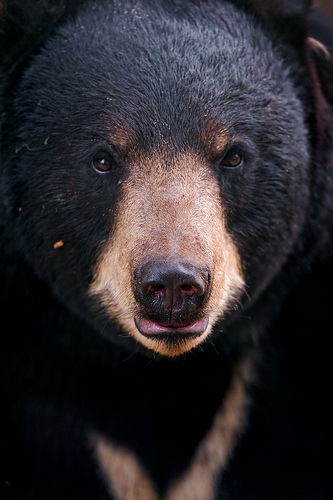Please provide a short description for this region: [0.33, 0.07, 0.59, 0.3]. The region within the coordinates [0.33, 0.07, 0.59, 0.3] displays dark fur on the bear. The rich, deep color of the fur in this area contrasts with lighter patches elsewhere on the bear's face. 